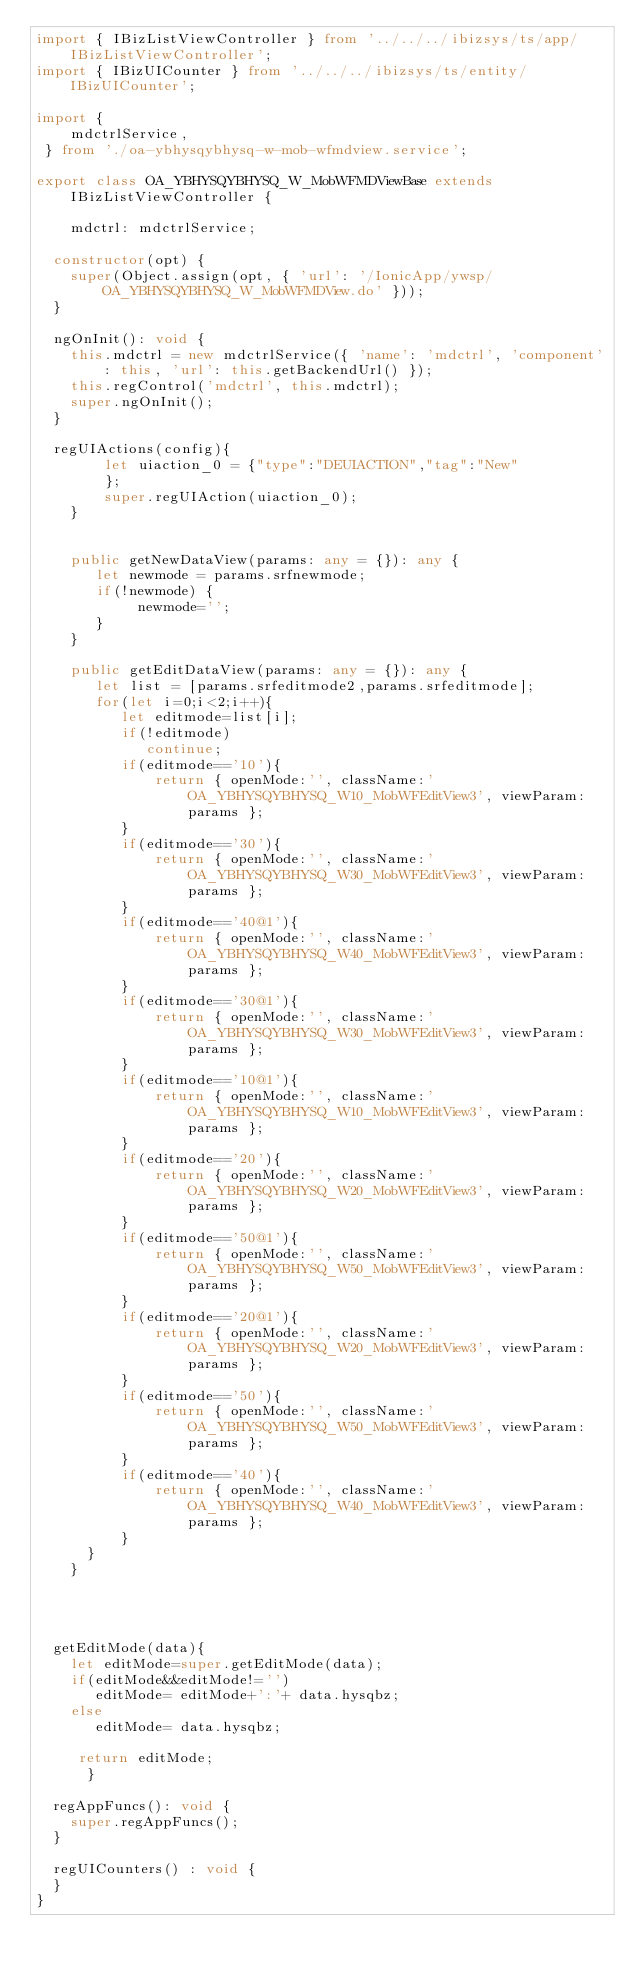Convert code to text. <code><loc_0><loc_0><loc_500><loc_500><_TypeScript_>import { IBizListViewController } from '../../../ibizsys/ts/app/IBizListViewController';
import { IBizUICounter } from '../../../ibizsys/ts/entity/IBizUICounter';

import {
	mdctrlService,
 } from './oa-ybhysqybhysq-w-mob-wfmdview.service';

export class OA_YBHYSQYBHYSQ_W_MobWFMDViewBase extends IBizListViewController {

    mdctrl: mdctrlService;

  constructor(opt) {
    super(Object.assign(opt, { 'url': '/IonicApp/ywsp/OA_YBHYSQYBHYSQ_W_MobWFMDView.do' }));
  }

  ngOnInit(): void {
    this.mdctrl = new mdctrlService({ 'name': 'mdctrl', 'component': this, 'url': this.getBackendUrl() });
    this.regControl('mdctrl', this.mdctrl);
    super.ngOnInit();
  }

  regUIActions(config){
        let uiaction_0 = {"type":"DEUIACTION","tag":"New"
        };
        super.regUIAction(uiaction_0);
    }


    public getNewDataView(params: any = {}): any {
       let newmode = params.srfnewmode;
       if(!newmode) {
            newmode='';
       }
    }

    public getEditDataView(params: any = {}): any {
       let list = [params.srfeditmode2,params.srfeditmode];
       for(let i=0;i<2;i++){
          let editmode=list[i];
          if(!editmode)
             continue;
          if(editmode=='10'){
              return { openMode:'', className:'OA_YBHYSQYBHYSQ_W10_MobWFEditView3', viewParam:params };
          }
          if(editmode=='30'){
              return { openMode:'', className:'OA_YBHYSQYBHYSQ_W30_MobWFEditView3', viewParam:params };
          }
          if(editmode=='40@1'){
              return { openMode:'', className:'OA_YBHYSQYBHYSQ_W40_MobWFEditView3', viewParam:params };
          }
          if(editmode=='30@1'){
              return { openMode:'', className:'OA_YBHYSQYBHYSQ_W30_MobWFEditView3', viewParam:params };
          }
          if(editmode=='10@1'){
              return { openMode:'', className:'OA_YBHYSQYBHYSQ_W10_MobWFEditView3', viewParam:params };
          }
          if(editmode=='20'){
              return { openMode:'', className:'OA_YBHYSQYBHYSQ_W20_MobWFEditView3', viewParam:params };
          }
          if(editmode=='50@1'){
              return { openMode:'', className:'OA_YBHYSQYBHYSQ_W50_MobWFEditView3', viewParam:params };
          }
          if(editmode=='20@1'){
              return { openMode:'', className:'OA_YBHYSQYBHYSQ_W20_MobWFEditView3', viewParam:params };
          }
          if(editmode=='50'){
              return { openMode:'', className:'OA_YBHYSQYBHYSQ_W50_MobWFEditView3', viewParam:params };
          }
          if(editmode=='40'){
              return { openMode:'', className:'OA_YBHYSQYBHYSQ_W40_MobWFEditView3', viewParam:params };
          }
      }
    }
    



  getEditMode(data){
    let editMode=super.getEditMode(data);
    if(editMode&&editMode!='')
       editMode= editMode+':'+ data.hysqbz;
    else 
       editMode= data.hysqbz;
      
     return editMode;
      }

  regAppFuncs(): void {
    super.regAppFuncs();
  }

  regUICounters() : void {
  }
}</code> 